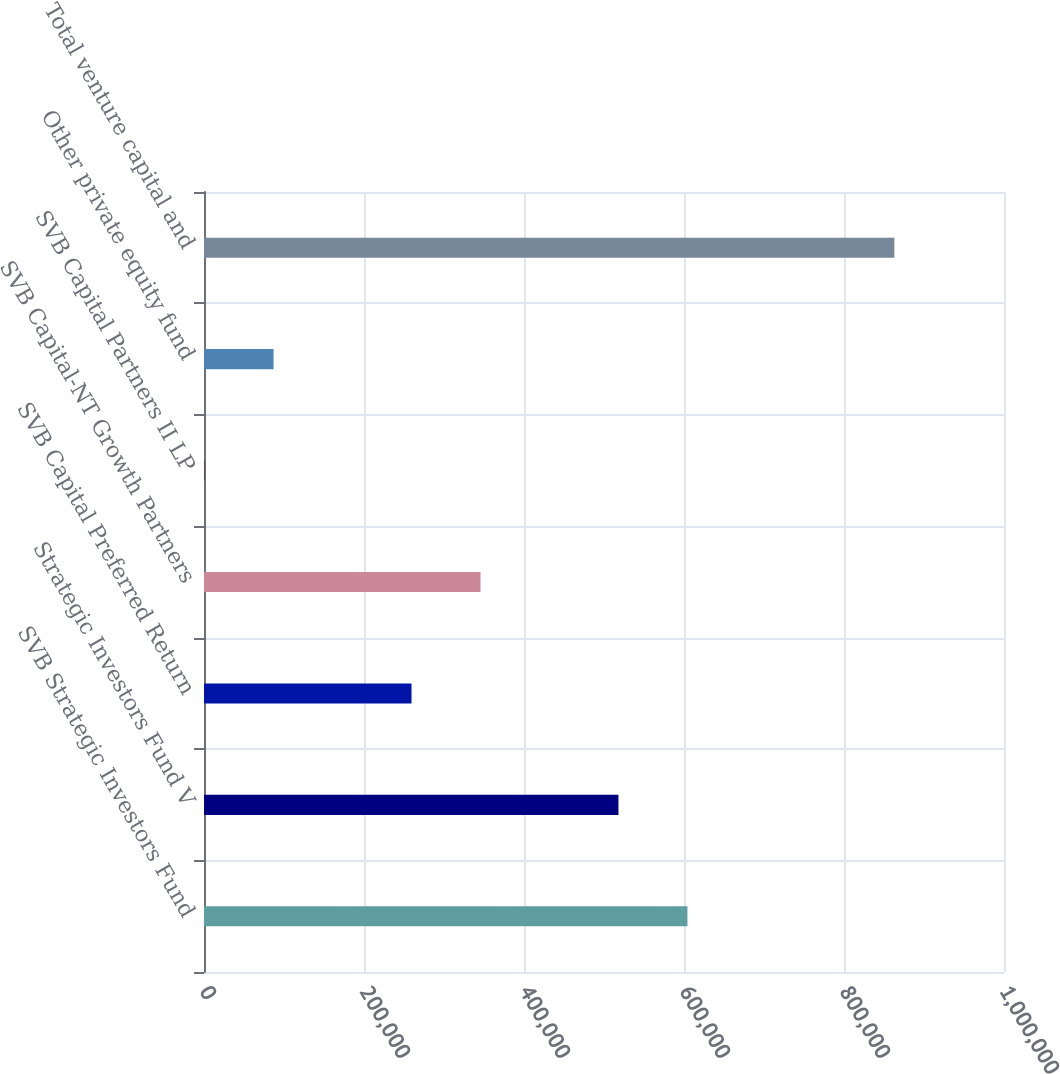Convert chart. <chart><loc_0><loc_0><loc_500><loc_500><bar_chart><fcel>SVB Strategic Investors Fund<fcel>Strategic Investors Fund V<fcel>SVB Capital Preferred Return<fcel>SVB Capital-NT Growth Partners<fcel>SVB Capital Partners II LP<fcel>Other private equity fund<fcel>Total venture capital and<nl><fcel>604293<fcel>518066<fcel>259387<fcel>345614<fcel>708<fcel>86934.4<fcel>862972<nl></chart> 